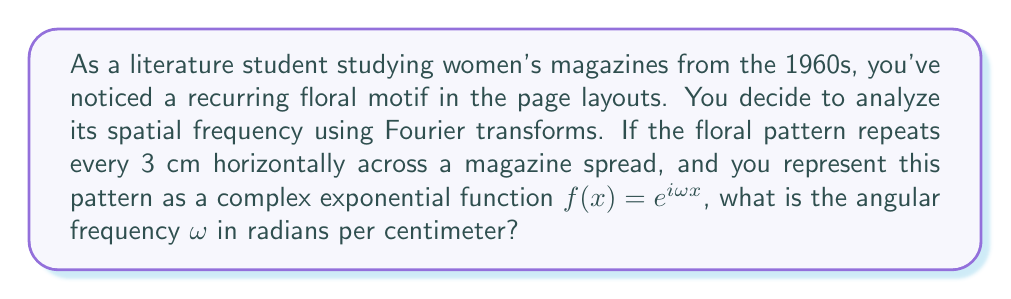Could you help me with this problem? To solve this problem, we need to understand the relationship between spatial frequency and angular frequency in the context of Fourier transforms.

1) The spatial frequency is the number of repetitions of a pattern per unit distance. In this case, the pattern repeats every 3 cm.

2) The spatial period $T$ is therefore 3 cm.

3) The spatial frequency $f$ is the inverse of the period:

   $f = \frac{1}{T} = \frac{1}{3}$ cycles/cm

4) In the complex exponential function $f(x) = e^{i\omega x}$, $\omega$ represents the angular frequency in radians per unit distance.

5) The relationship between angular frequency $\omega$ and spatial frequency $f$ is:

   $\omega = 2\pi f$

6) Substituting our spatial frequency:

   $\omega = 2\pi \cdot \frac{1}{3}$

7) Simplifying:

   $\omega = \frac{2\pi}{3}$ radians/cm

Therefore, the angular frequency $\omega$ of the floral motif is $\frac{2\pi}{3}$ radians per centimeter.
Answer: $\omega = \frac{2\pi}{3}$ radians/cm 